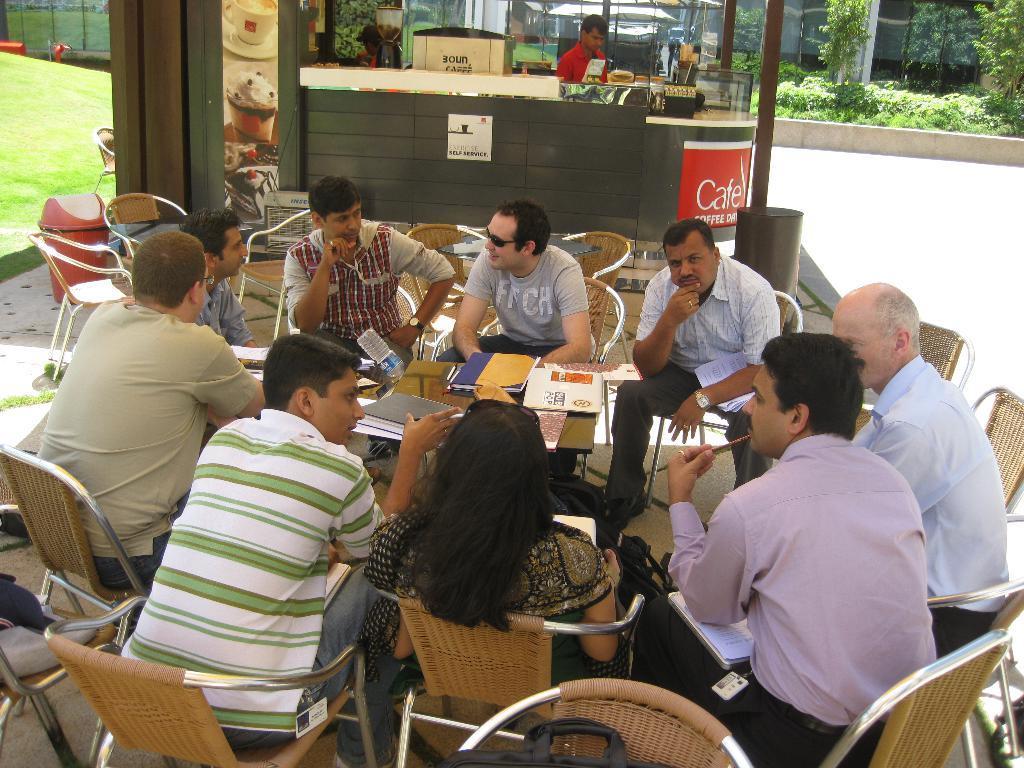Could you give a brief overview of what you see in this image? Group of people are sitting on the chairs around the table. On the right there are plants. 